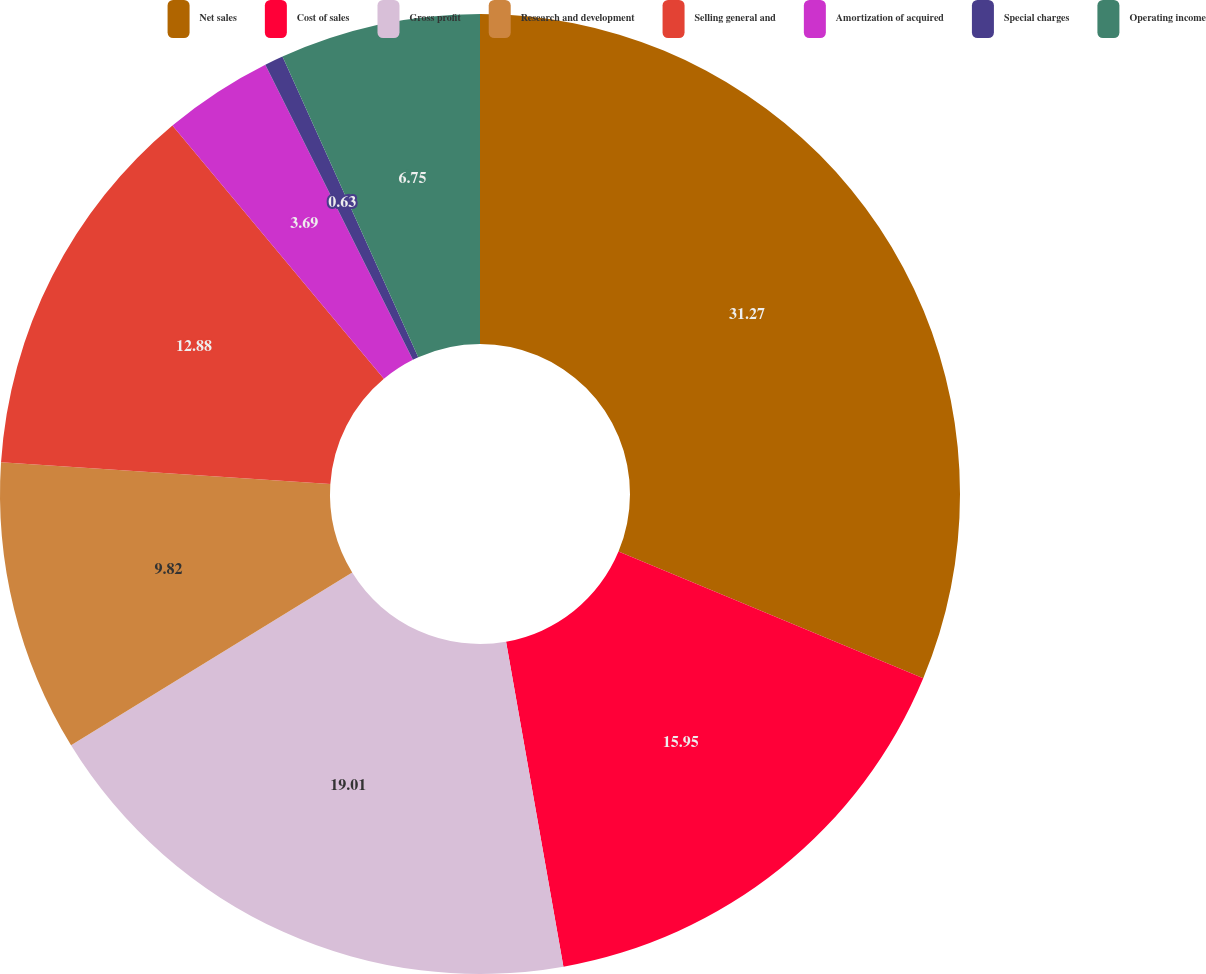Convert chart to OTSL. <chart><loc_0><loc_0><loc_500><loc_500><pie_chart><fcel>Net sales<fcel>Cost of sales<fcel>Gross profit<fcel>Research and development<fcel>Selling general and<fcel>Amortization of acquired<fcel>Special charges<fcel>Operating income<nl><fcel>31.27%<fcel>15.95%<fcel>19.01%<fcel>9.82%<fcel>12.88%<fcel>3.69%<fcel>0.63%<fcel>6.75%<nl></chart> 